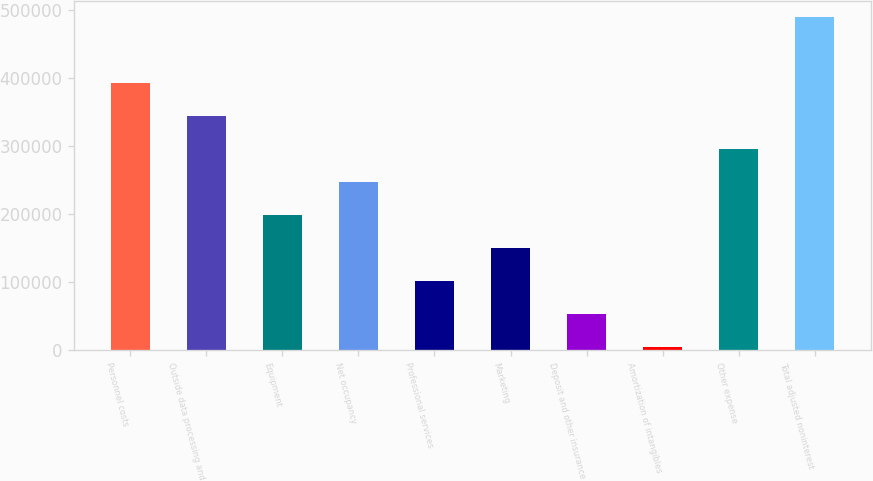Convert chart. <chart><loc_0><loc_0><loc_500><loc_500><bar_chart><fcel>Personnel costs<fcel>Outside data processing and<fcel>Equipment<fcel>Net occupancy<fcel>Professional services<fcel>Marketing<fcel>Deposit and other insurance<fcel>Amortization of intangibles<fcel>Other expense<fcel>Total adjusted noninterest<nl><fcel>391378<fcel>342930<fcel>197583<fcel>246032<fcel>100686<fcel>149134<fcel>52236.8<fcel>3788<fcel>294481<fcel>488276<nl></chart> 